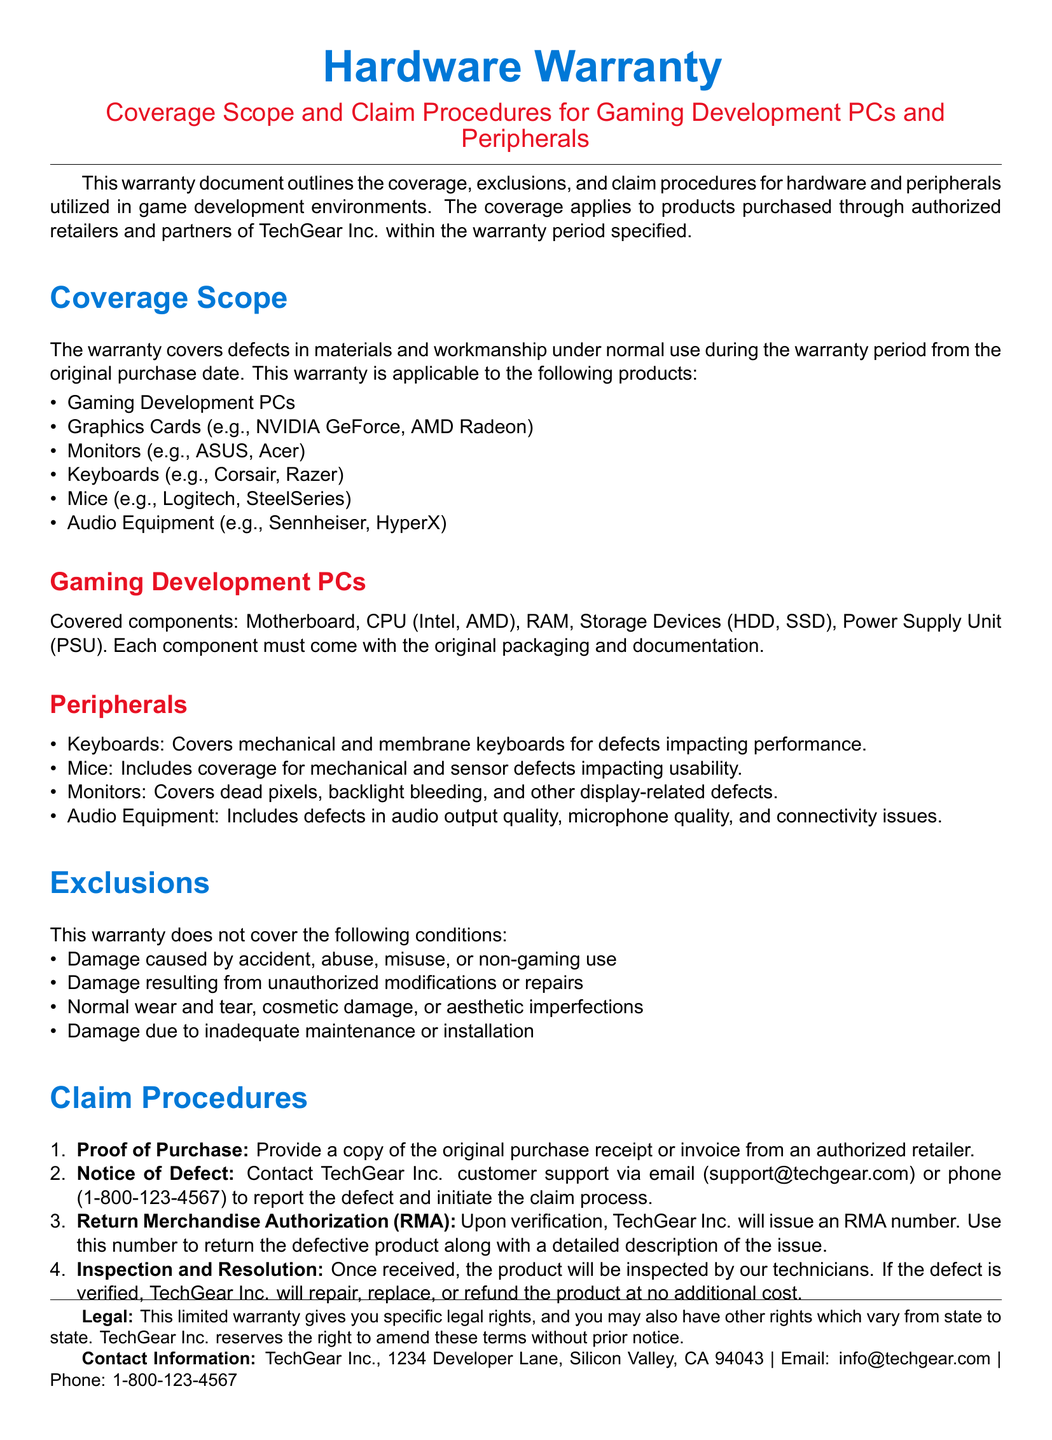What is the company name? The company mentioned in the document is responsible for the warranty and its products.
Answer: TechGear Inc What is the warranty period based on? The warranty period applies to hardware and peripherals purchased within a specific timeframe.
Answer: Original purchase date Which items are excluded from warranty coverage? The document lists certain conditions that disqualify items from warranty coverage.
Answer: Damage caused by accident What types of gaming development PCs components are covered? The warranty specifically mentions which PC components are included.
Answer: Motherboard, CPU, RAM, Storage Devices, Power Supply Unit What is the first step in the claim procedure? The claim procedure is outlined in a numbered format, starting with a specific requirement.
Answer: Proof of Purchase What must be provided to initiate the claim process? The claim process requires something specific from the customer to begin.
Answer: Original purchase receipt What type of warranty is described in the document? The document describes the nature of the warranty provided by the company.
Answer: Limited warranty What types of products are covered under the warranty? The document identifies a category of products applicable for warranty coverage.
Answer: Gaming Development PCs and Peripherals What email can be used to contact customer support? The document provides contact information, including an email address for customer inquiries.
Answer: support@techgear.com 